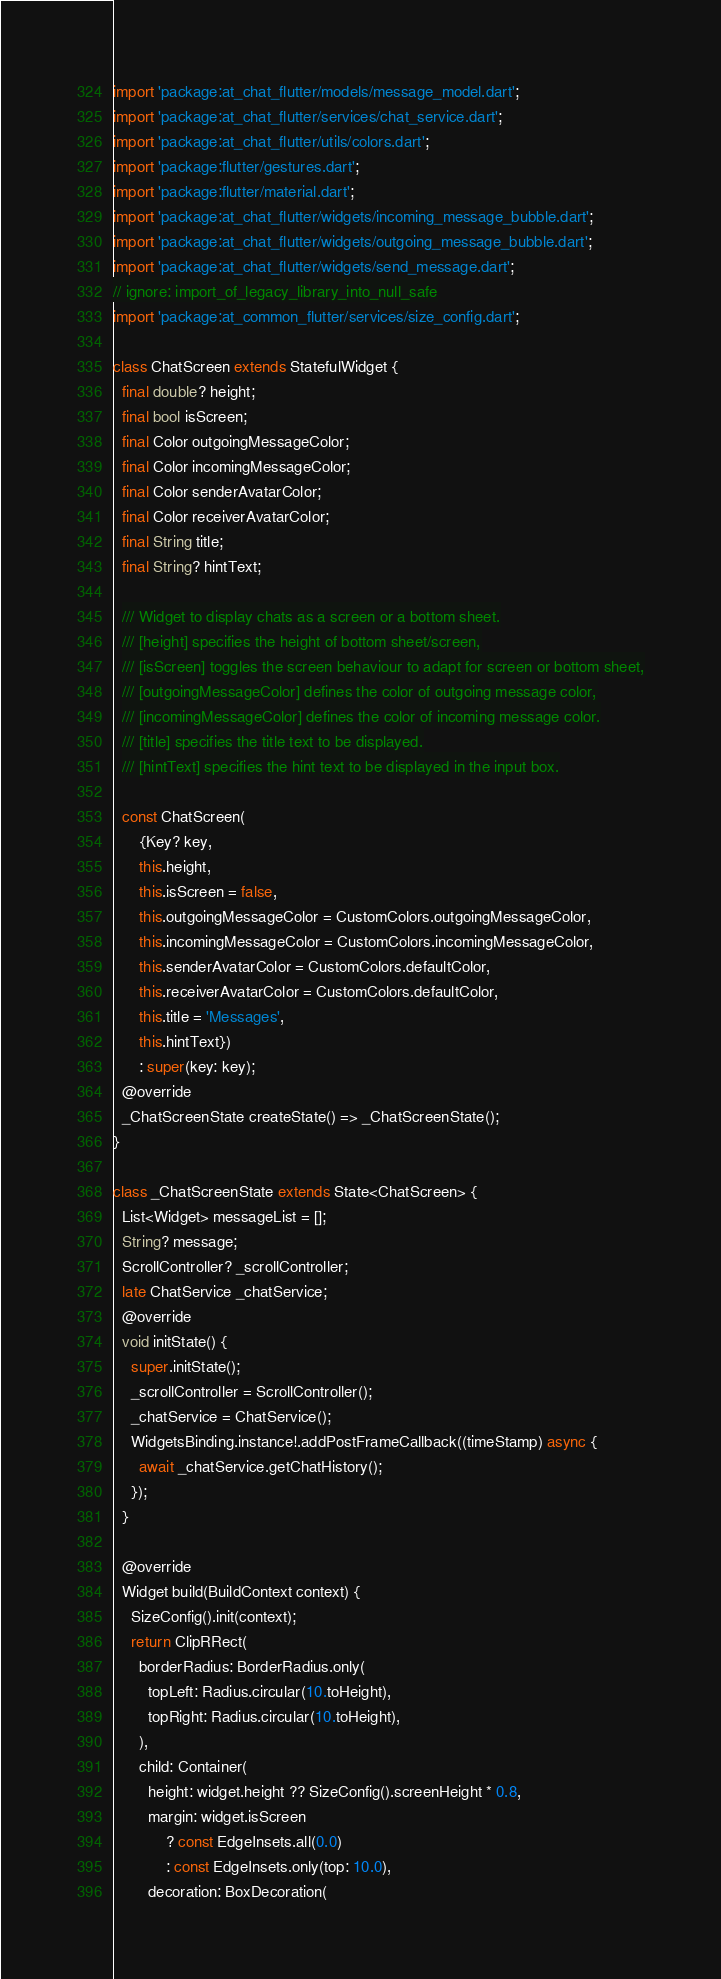Convert code to text. <code><loc_0><loc_0><loc_500><loc_500><_Dart_>import 'package:at_chat_flutter/models/message_model.dart';
import 'package:at_chat_flutter/services/chat_service.dart';
import 'package:at_chat_flutter/utils/colors.dart';
import 'package:flutter/gestures.dart';
import 'package:flutter/material.dart';
import 'package:at_chat_flutter/widgets/incoming_message_bubble.dart';
import 'package:at_chat_flutter/widgets/outgoing_message_bubble.dart';
import 'package:at_chat_flutter/widgets/send_message.dart';
// ignore: import_of_legacy_library_into_null_safe
import 'package:at_common_flutter/services/size_config.dart';

class ChatScreen extends StatefulWidget {
  final double? height;
  final bool isScreen;
  final Color outgoingMessageColor;
  final Color incomingMessageColor;
  final Color senderAvatarColor;
  final Color receiverAvatarColor;
  final String title;
  final String? hintText;

  /// Widget to display chats as a screen or a bottom sheet.
  /// [height] specifies the height of bottom sheet/screen,
  /// [isScreen] toggles the screen behaviour to adapt for screen or bottom sheet,
  /// [outgoingMessageColor] defines the color of outgoing message color,
  /// [incomingMessageColor] defines the color of incoming message color.
  /// [title] specifies the title text to be displayed.
  /// [hintText] specifies the hint text to be displayed in the input box.

  const ChatScreen(
      {Key? key,
      this.height,
      this.isScreen = false,
      this.outgoingMessageColor = CustomColors.outgoingMessageColor,
      this.incomingMessageColor = CustomColors.incomingMessageColor,
      this.senderAvatarColor = CustomColors.defaultColor,
      this.receiverAvatarColor = CustomColors.defaultColor,
      this.title = 'Messages',
      this.hintText})
      : super(key: key);
  @override
  _ChatScreenState createState() => _ChatScreenState();
}

class _ChatScreenState extends State<ChatScreen> {
  List<Widget> messageList = [];
  String? message;
  ScrollController? _scrollController;
  late ChatService _chatService;
  @override
  void initState() {
    super.initState();
    _scrollController = ScrollController();
    _chatService = ChatService();
    WidgetsBinding.instance!.addPostFrameCallback((timeStamp) async {
      await _chatService.getChatHistory();
    });
  }

  @override
  Widget build(BuildContext context) {
    SizeConfig().init(context);
    return ClipRRect(
      borderRadius: BorderRadius.only(
        topLeft: Radius.circular(10.toHeight),
        topRight: Radius.circular(10.toHeight),
      ),
      child: Container(
        height: widget.height ?? SizeConfig().screenHeight * 0.8,
        margin: widget.isScreen
            ? const EdgeInsets.all(0.0)
            : const EdgeInsets.only(top: 10.0),
        decoration: BoxDecoration(</code> 